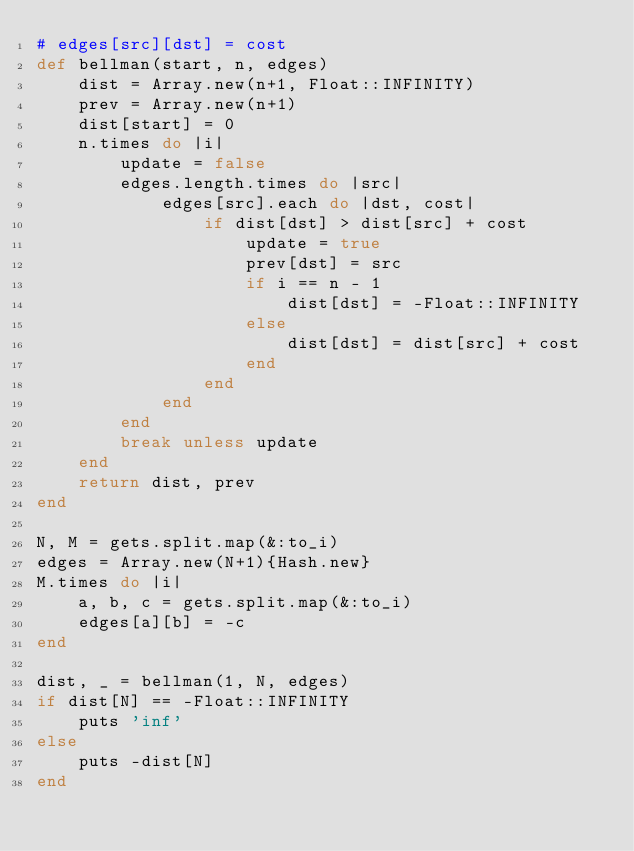<code> <loc_0><loc_0><loc_500><loc_500><_Ruby_># edges[src][dst] = cost
def bellman(start, n, edges)
    dist = Array.new(n+1, Float::INFINITY)
    prev = Array.new(n+1)
    dist[start] = 0
    n.times do |i|
        update = false
        edges.length.times do |src|
            edges[src].each do |dst, cost|
                if dist[dst] > dist[src] + cost
                    update = true
                    prev[dst] = src
                    if i == n - 1
                        dist[dst] = -Float::INFINITY
                    else
                        dist[dst] = dist[src] + cost
                    end
                end
            end
        end
        break unless update
    end
    return dist, prev
end

N, M = gets.split.map(&:to_i)
edges = Array.new(N+1){Hash.new}
M.times do |i|
    a, b, c = gets.split.map(&:to_i)
    edges[a][b] = -c
end

dist, _ = bellman(1, N, edges)
if dist[N] == -Float::INFINITY
    puts 'inf'
else
    puts -dist[N]
end</code> 